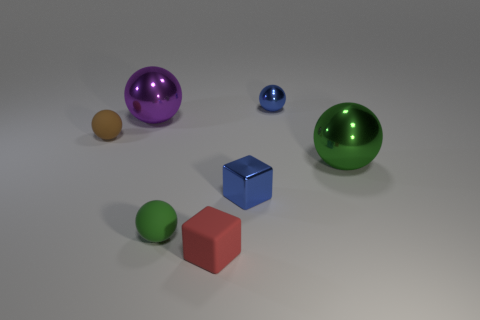Are there any matte things on the right side of the large purple metal ball?
Ensure brevity in your answer.  Yes. The tiny metallic ball that is on the right side of the matte thing that is behind the big metallic object on the right side of the small metal block is what color?
Your response must be concise. Blue. Is the purple shiny thing the same shape as the big green object?
Ensure brevity in your answer.  Yes. What is the color of the other large sphere that is the same material as the purple ball?
Make the answer very short. Green. How many objects are either small rubber things that are right of the large purple object or tiny blue spheres?
Provide a succinct answer. 3. What is the size of the green object that is right of the tiny matte block?
Offer a very short reply. Large. There is a red thing; is its size the same as the blue object that is behind the large green sphere?
Give a very brief answer. Yes. What is the color of the small rubber sphere that is in front of the small matte object that is behind the green matte ball?
Keep it short and to the point. Green. What number of other things are there of the same color as the small rubber block?
Make the answer very short. 0. The blue shiny sphere is what size?
Offer a very short reply. Small. 